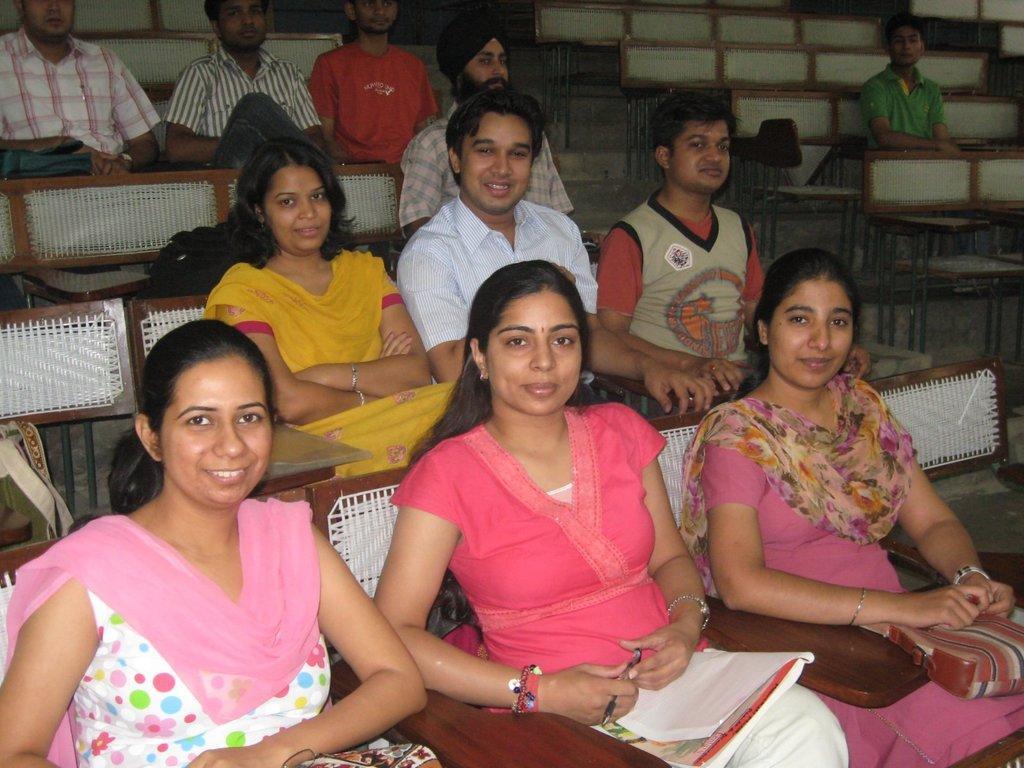Can you describe this image briefly? In this image I can see group of people sitting. In front the person is wearing pink and white color dress and the person at right is holding a pen and I can also see the book. 